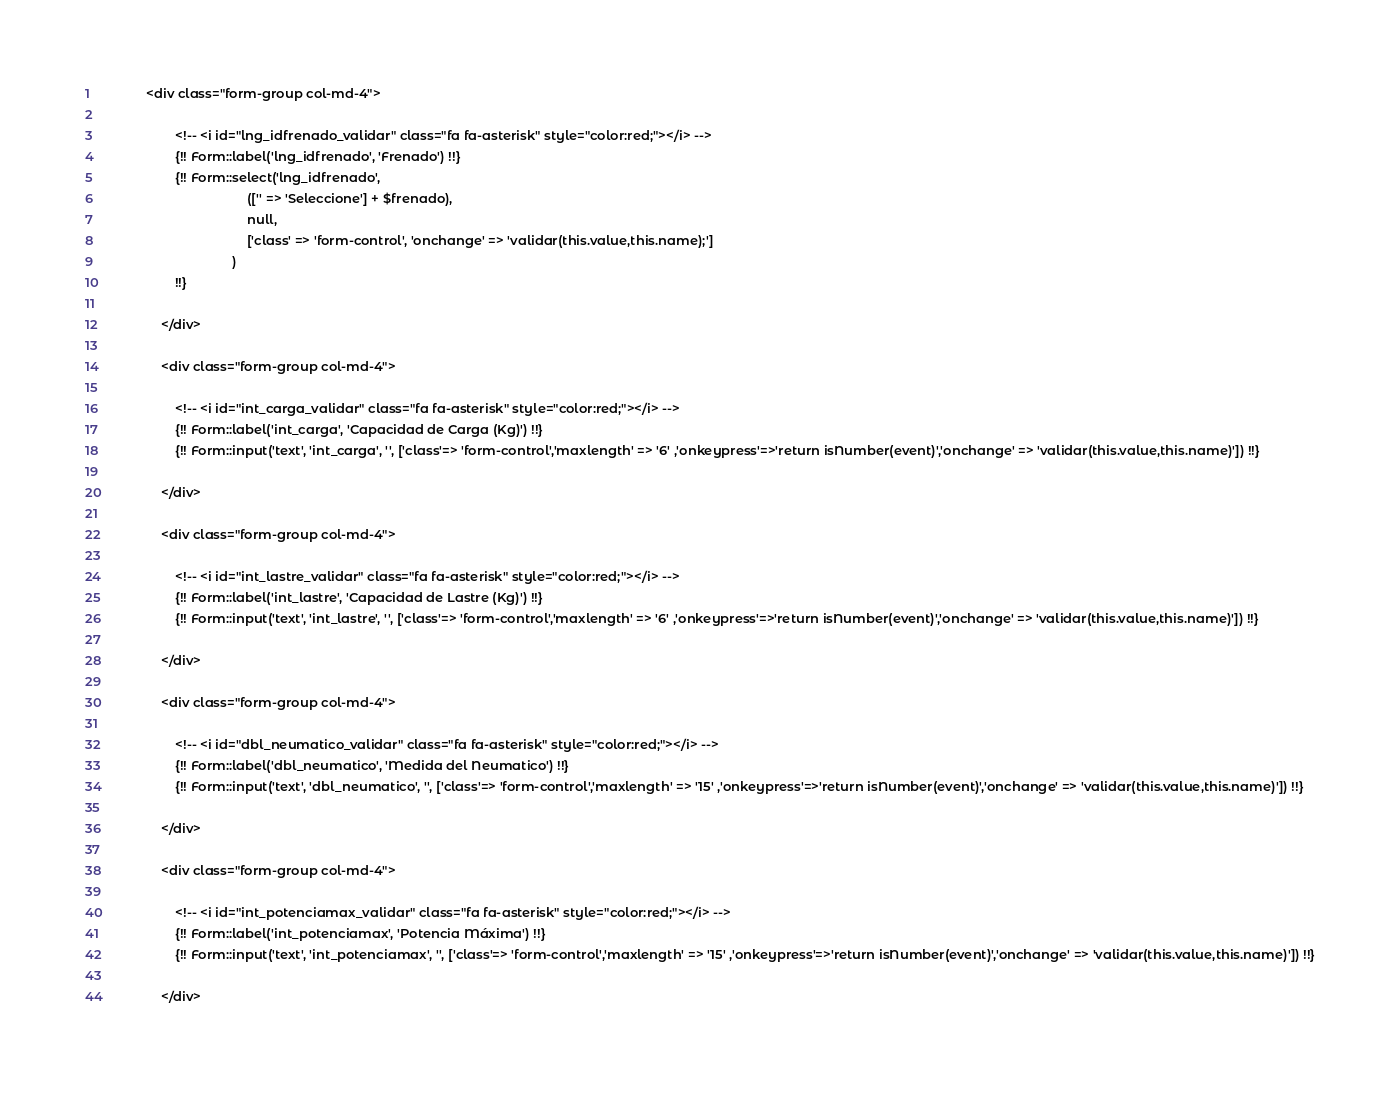Convert code to text. <code><loc_0><loc_0><loc_500><loc_500><_PHP_>            <div class="form-group col-md-4">
                    
                    <!-- <i id="lng_idfrenado_validar" class="fa fa-asterisk" style="color:red;"></i> -->
                    {!! Form::label('lng_idfrenado', 'Frenado') !!}
                    {!! Form::select('lng_idfrenado', 
                                        (['' => 'Seleccione'] + $frenado), 
                                        null, 
                                        ['class' => 'form-control', 'onchange' => 'validar(this.value,this.name);']
                                    ) 
                    !!} 

                </div>

                <div class="form-group col-md-4">
                    
                    <!-- <i id="int_carga_validar" class="fa fa-asterisk" style="color:red;"></i> -->
                    {!! Form::label('int_carga', 'Capacidad de Carga (Kg)') !!}
                    {!! Form::input('text', 'int_carga', '', ['class'=> 'form-control','maxlength' => '6' ,'onkeypress'=>'return isNumber(event)','onchange' => 'validar(this.value,this.name)']) !!}
        
                </div>

                <div class="form-group col-md-4">
                    
                    <!-- <i id="int_lastre_validar" class="fa fa-asterisk" style="color:red;"></i> -->
                    {!! Form::label('int_lastre', 'Capacidad de Lastre (Kg)') !!}
                    {!! Form::input('text', 'int_lastre', '', ['class'=> 'form-control','maxlength' => '6' ,'onkeypress'=>'return isNumber(event)','onchange' => 'validar(this.value,this.name)']) !!}
        
                </div>

                <div class="form-group col-md-4">
                    
                    <!-- <i id="dbl_neumatico_validar" class="fa fa-asterisk" style="color:red;"></i> -->
                    {!! Form::label('dbl_neumatico', 'Medida del Neumatico') !!}
                    {!! Form::input('text', 'dbl_neumatico', '', ['class'=> 'form-control','maxlength' => '15' ,'onkeypress'=>'return isNumber(event)','onchange' => 'validar(this.value,this.name)']) !!}
        
                </div>

                <div class="form-group col-md-4">
                    
                    <!-- <i id="int_potenciamax_validar" class="fa fa-asterisk" style="color:red;"></i> -->
                    {!! Form::label('int_potenciamax', 'Potencia Máxima') !!}
                    {!! Form::input('text', 'int_potenciamax', '', ['class'=> 'form-control','maxlength' => '15' ,'onkeypress'=>'return isNumber(event)','onchange' => 'validar(this.value,this.name)']) !!}
        
                </div></code> 